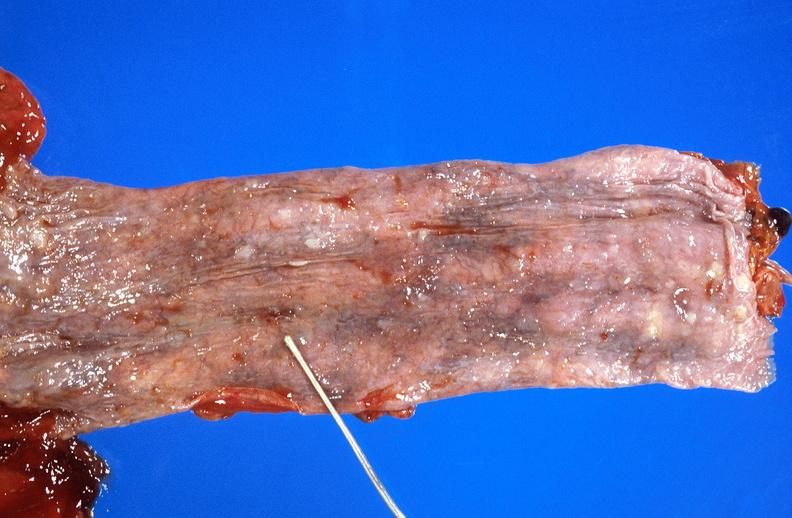what does this image show?
Answer the question using a single word or phrase. Esophageal varices due to alcoholic cirrhosis 